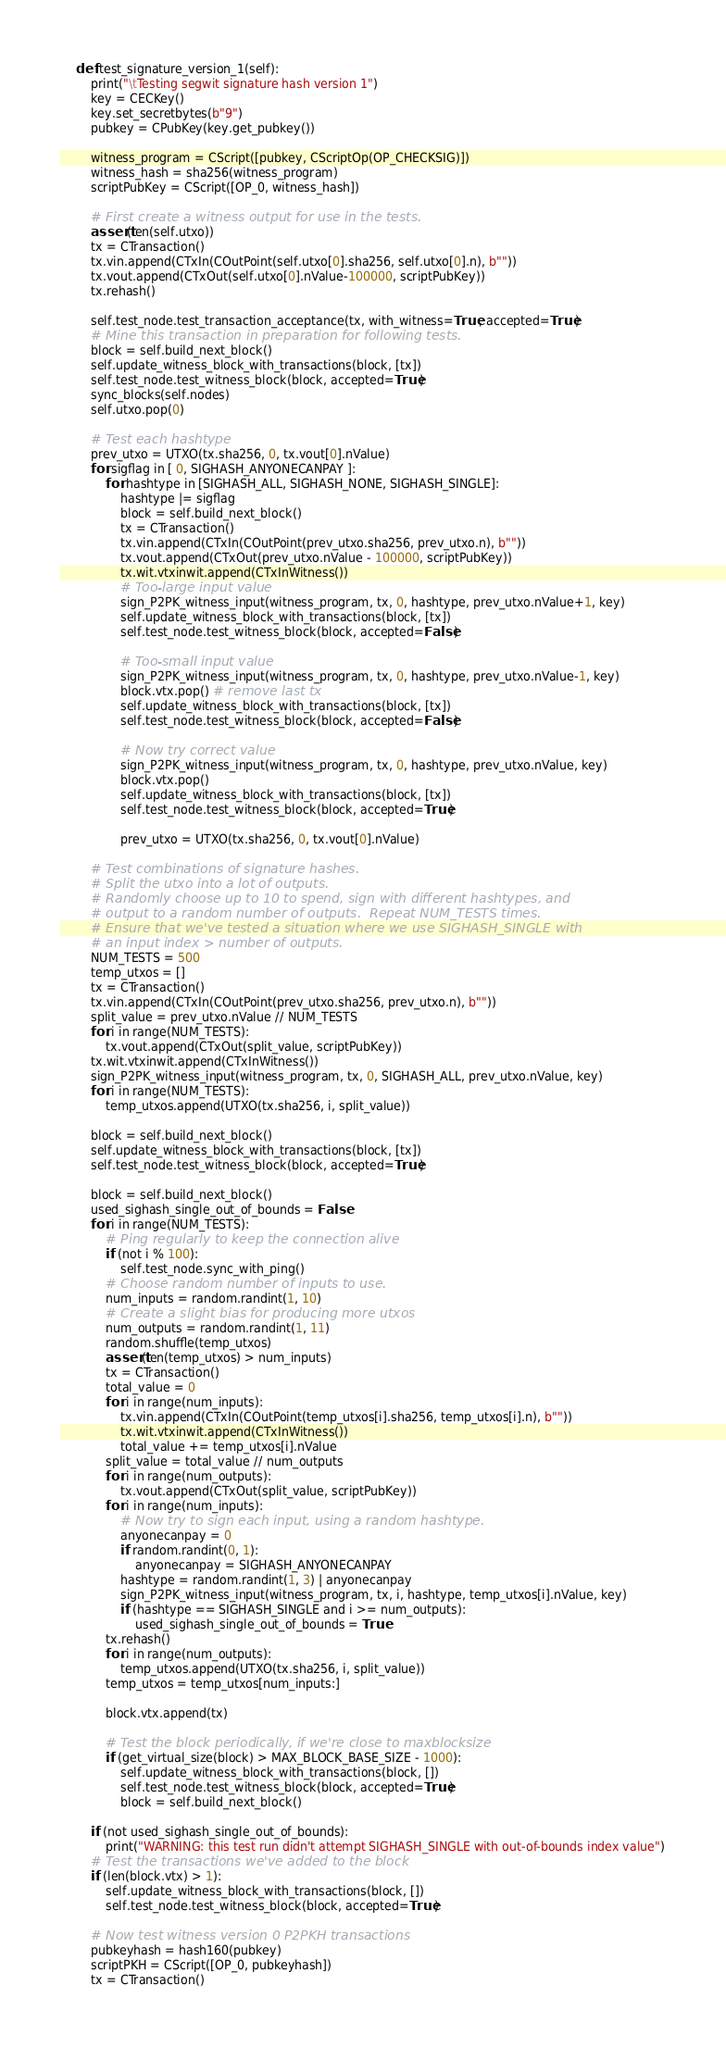Convert code to text. <code><loc_0><loc_0><loc_500><loc_500><_Python_>    def test_signature_version_1(self):
        print("\tTesting segwit signature hash version 1")
        key = CECKey()
        key.set_secretbytes(b"9")
        pubkey = CPubKey(key.get_pubkey())

        witness_program = CScript([pubkey, CScriptOp(OP_CHECKSIG)])
        witness_hash = sha256(witness_program)
        scriptPubKey = CScript([OP_0, witness_hash])

        # First create a witness output for use in the tests.
        assert(len(self.utxo))
        tx = CTransaction()
        tx.vin.append(CTxIn(COutPoint(self.utxo[0].sha256, self.utxo[0].n), b""))
        tx.vout.append(CTxOut(self.utxo[0].nValue-100000, scriptPubKey))
        tx.rehash()

        self.test_node.test_transaction_acceptance(tx, with_witness=True, accepted=True)
        # Mine this transaction in preparation for following tests.
        block = self.build_next_block()
        self.update_witness_block_with_transactions(block, [tx])
        self.test_node.test_witness_block(block, accepted=True)
        sync_blocks(self.nodes)
        self.utxo.pop(0)

        # Test each hashtype
        prev_utxo = UTXO(tx.sha256, 0, tx.vout[0].nValue)
        for sigflag in [ 0, SIGHASH_ANYONECANPAY ]:
            for hashtype in [SIGHASH_ALL, SIGHASH_NONE, SIGHASH_SINGLE]:
                hashtype |= sigflag
                block = self.build_next_block()
                tx = CTransaction()
                tx.vin.append(CTxIn(COutPoint(prev_utxo.sha256, prev_utxo.n), b""))
                tx.vout.append(CTxOut(prev_utxo.nValue - 100000, scriptPubKey))
                tx.wit.vtxinwit.append(CTxInWitness())
                # Too-large input value
                sign_P2PK_witness_input(witness_program, tx, 0, hashtype, prev_utxo.nValue+1, key)
                self.update_witness_block_with_transactions(block, [tx])
                self.test_node.test_witness_block(block, accepted=False)

                # Too-small input value
                sign_P2PK_witness_input(witness_program, tx, 0, hashtype, prev_utxo.nValue-1, key)
                block.vtx.pop() # remove last tx
                self.update_witness_block_with_transactions(block, [tx])
                self.test_node.test_witness_block(block, accepted=False)

                # Now try correct value
                sign_P2PK_witness_input(witness_program, tx, 0, hashtype, prev_utxo.nValue, key)
                block.vtx.pop()
                self.update_witness_block_with_transactions(block, [tx])
                self.test_node.test_witness_block(block, accepted=True)

                prev_utxo = UTXO(tx.sha256, 0, tx.vout[0].nValue)

        # Test combinations of signature hashes.
        # Split the utxo into a lot of outputs.
        # Randomly choose up to 10 to spend, sign with different hashtypes, and
        # output to a random number of outputs.  Repeat NUM_TESTS times.
        # Ensure that we've tested a situation where we use SIGHASH_SINGLE with
        # an input index > number of outputs.
        NUM_TESTS = 500
        temp_utxos = []
        tx = CTransaction()
        tx.vin.append(CTxIn(COutPoint(prev_utxo.sha256, prev_utxo.n), b""))
        split_value = prev_utxo.nValue // NUM_TESTS
        for i in range(NUM_TESTS):
            tx.vout.append(CTxOut(split_value, scriptPubKey))
        tx.wit.vtxinwit.append(CTxInWitness())
        sign_P2PK_witness_input(witness_program, tx, 0, SIGHASH_ALL, prev_utxo.nValue, key)
        for i in range(NUM_TESTS):
            temp_utxos.append(UTXO(tx.sha256, i, split_value))

        block = self.build_next_block()
        self.update_witness_block_with_transactions(block, [tx])
        self.test_node.test_witness_block(block, accepted=True)

        block = self.build_next_block()
        used_sighash_single_out_of_bounds = False
        for i in range(NUM_TESTS):
            # Ping regularly to keep the connection alive
            if (not i % 100):
                self.test_node.sync_with_ping()
            # Choose random number of inputs to use.
            num_inputs = random.randint(1, 10)
            # Create a slight bias for producing more utxos
            num_outputs = random.randint(1, 11)
            random.shuffle(temp_utxos)
            assert(len(temp_utxos) > num_inputs)
            tx = CTransaction()
            total_value = 0
            for i in range(num_inputs):
                tx.vin.append(CTxIn(COutPoint(temp_utxos[i].sha256, temp_utxos[i].n), b""))
                tx.wit.vtxinwit.append(CTxInWitness())
                total_value += temp_utxos[i].nValue
            split_value = total_value // num_outputs
            for i in range(num_outputs):
                tx.vout.append(CTxOut(split_value, scriptPubKey))
            for i in range(num_inputs):
                # Now try to sign each input, using a random hashtype.
                anyonecanpay = 0
                if random.randint(0, 1):
                    anyonecanpay = SIGHASH_ANYONECANPAY
                hashtype = random.randint(1, 3) | anyonecanpay
                sign_P2PK_witness_input(witness_program, tx, i, hashtype, temp_utxos[i].nValue, key)
                if (hashtype == SIGHASH_SINGLE and i >= num_outputs):
                    used_sighash_single_out_of_bounds = True
            tx.rehash()
            for i in range(num_outputs):
                temp_utxos.append(UTXO(tx.sha256, i, split_value))
            temp_utxos = temp_utxos[num_inputs:]

            block.vtx.append(tx)

            # Test the block periodically, if we're close to maxblocksize
            if (get_virtual_size(block) > MAX_BLOCK_BASE_SIZE - 1000):
                self.update_witness_block_with_transactions(block, [])
                self.test_node.test_witness_block(block, accepted=True)
                block = self.build_next_block()

        if (not used_sighash_single_out_of_bounds):
            print("WARNING: this test run didn't attempt SIGHASH_SINGLE with out-of-bounds index value")
        # Test the transactions we've added to the block
        if (len(block.vtx) > 1):
            self.update_witness_block_with_transactions(block, [])
            self.test_node.test_witness_block(block, accepted=True)

        # Now test witness version 0 P2PKH transactions
        pubkeyhash = hash160(pubkey)
        scriptPKH = CScript([OP_0, pubkeyhash])
        tx = CTransaction()</code> 